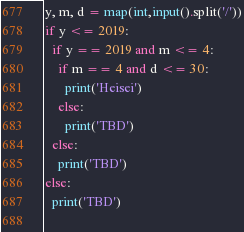Convert code to text. <code><loc_0><loc_0><loc_500><loc_500><_Python_>y, m, d = map(int,input().split('/'))
if y <= 2019:
  if y == 2019 and m <= 4:
    if m == 4 and d <= 30:
      print('Heisei')
    else:
      print('TBD')
  else:
    print('TBD')
else:
  print('TBD')
    </code> 